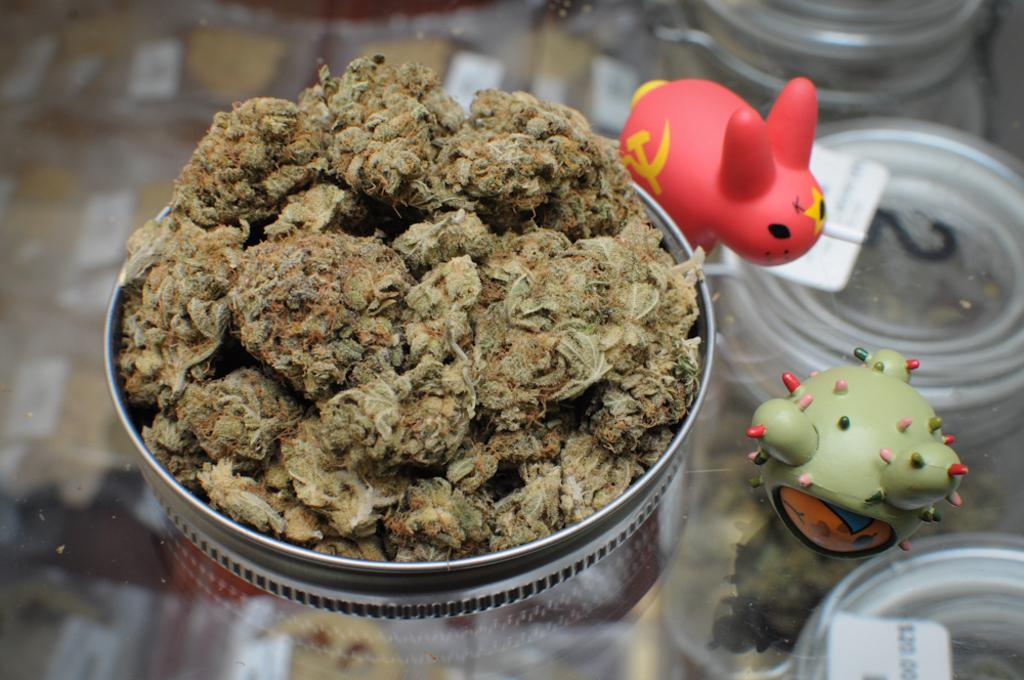What is on the plate that is visible in the image? The plate contains weed. What else can be seen near the plate in the image? There are toys beside the plate. On what surface is the plate placed? The plate is placed on a glass table. What type of badge is pinned to the weed on the plate? There is no badge present on the weed in the image. Can you describe the coil shape in the image? There is no coil shape present in the image. 